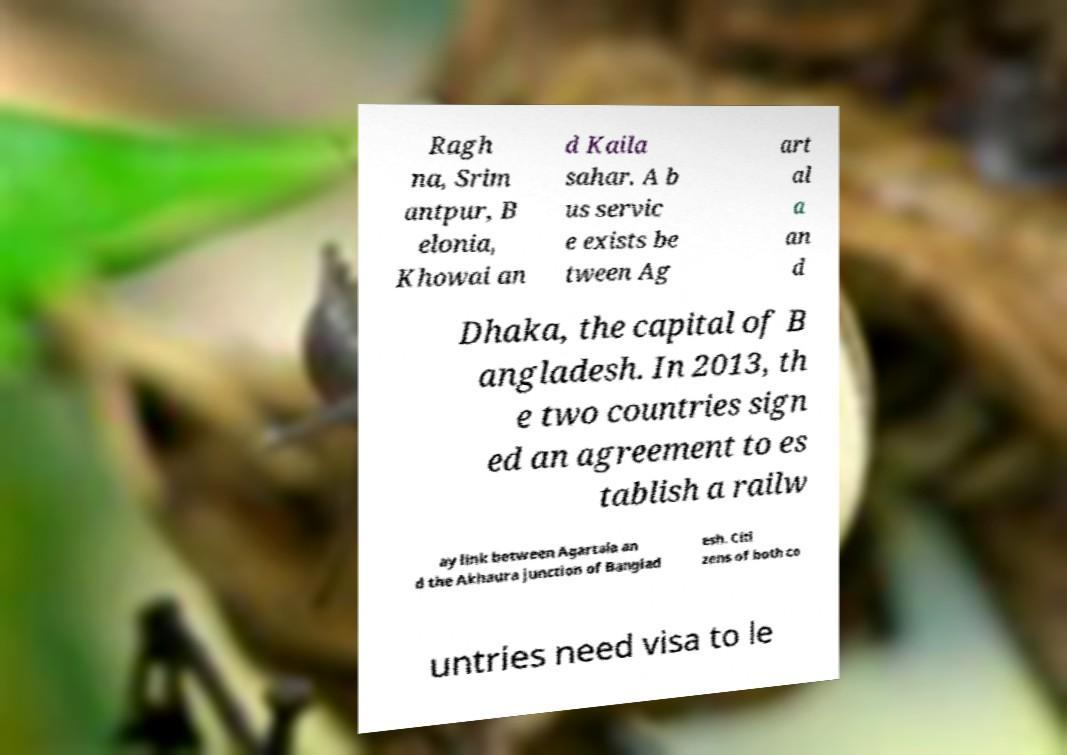Could you extract and type out the text from this image? Ragh na, Srim antpur, B elonia, Khowai an d Kaila sahar. A b us servic e exists be tween Ag art al a an d Dhaka, the capital of B angladesh. In 2013, th e two countries sign ed an agreement to es tablish a railw ay link between Agartala an d the Akhaura junction of Banglad esh. Citi zens of both co untries need visa to le 